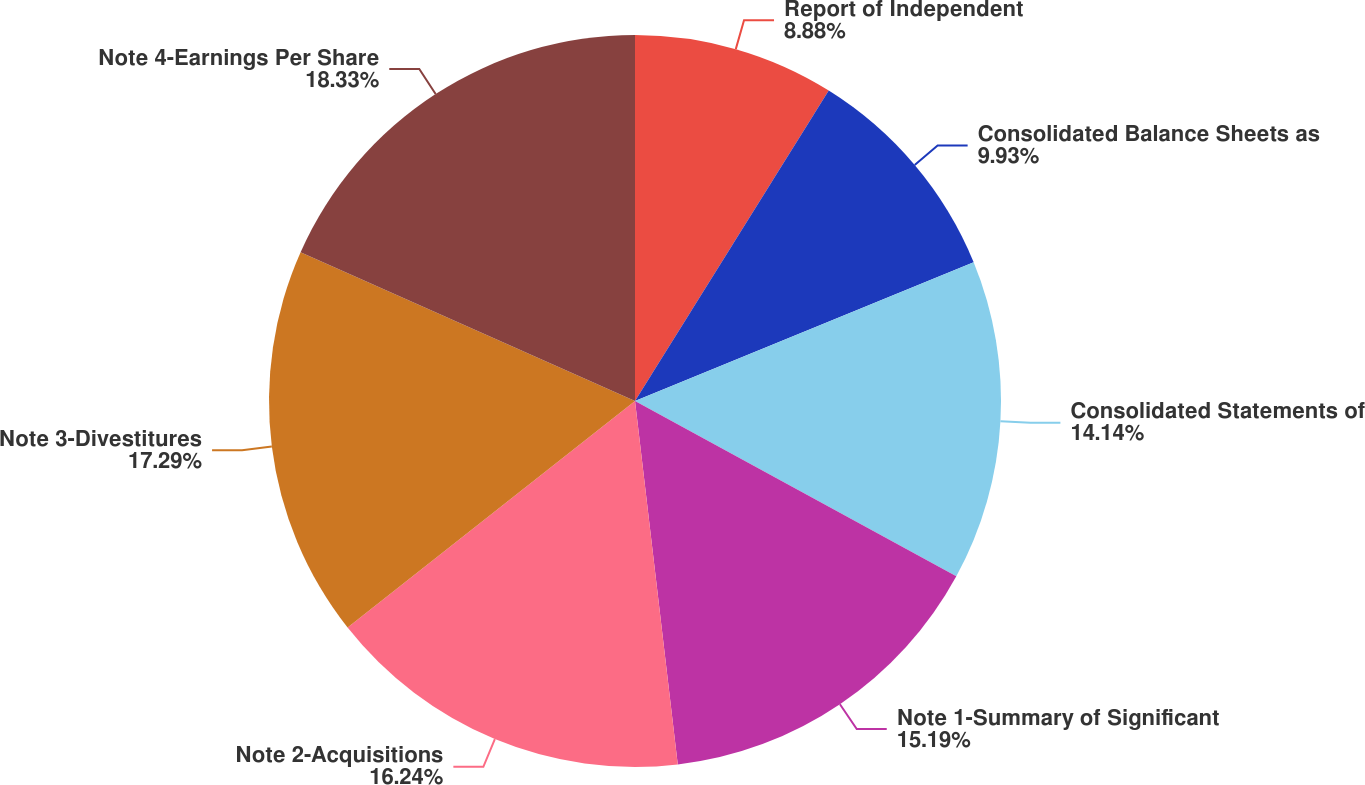Convert chart. <chart><loc_0><loc_0><loc_500><loc_500><pie_chart><fcel>Report of Independent<fcel>Consolidated Balance Sheets as<fcel>Consolidated Statements of<fcel>Note 1-Summary of Significant<fcel>Note 2-Acquisitions<fcel>Note 3-Divestitures<fcel>Note 4-Earnings Per Share<nl><fcel>8.88%<fcel>9.93%<fcel>14.14%<fcel>15.19%<fcel>16.24%<fcel>17.29%<fcel>18.34%<nl></chart> 